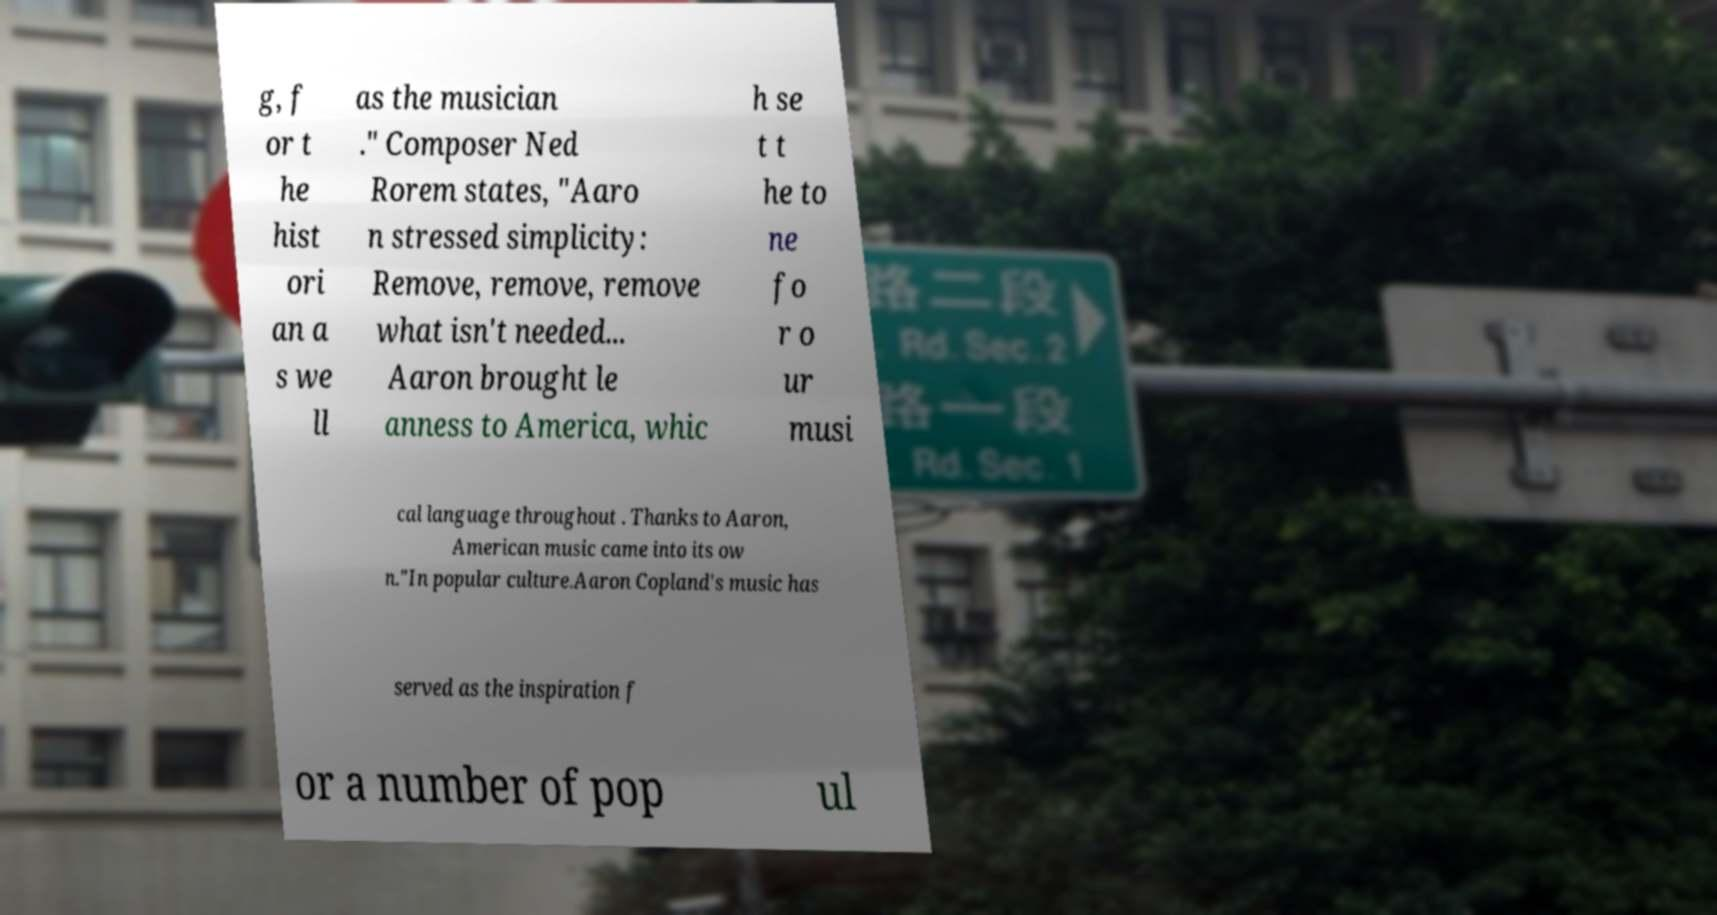Please identify and transcribe the text found in this image. g, f or t he hist ori an a s we ll as the musician ." Composer Ned Rorem states, "Aaro n stressed simplicity: Remove, remove, remove what isn't needed... Aaron brought le anness to America, whic h se t t he to ne fo r o ur musi cal language throughout . Thanks to Aaron, American music came into its ow n."In popular culture.Aaron Copland's music has served as the inspiration f or a number of pop ul 